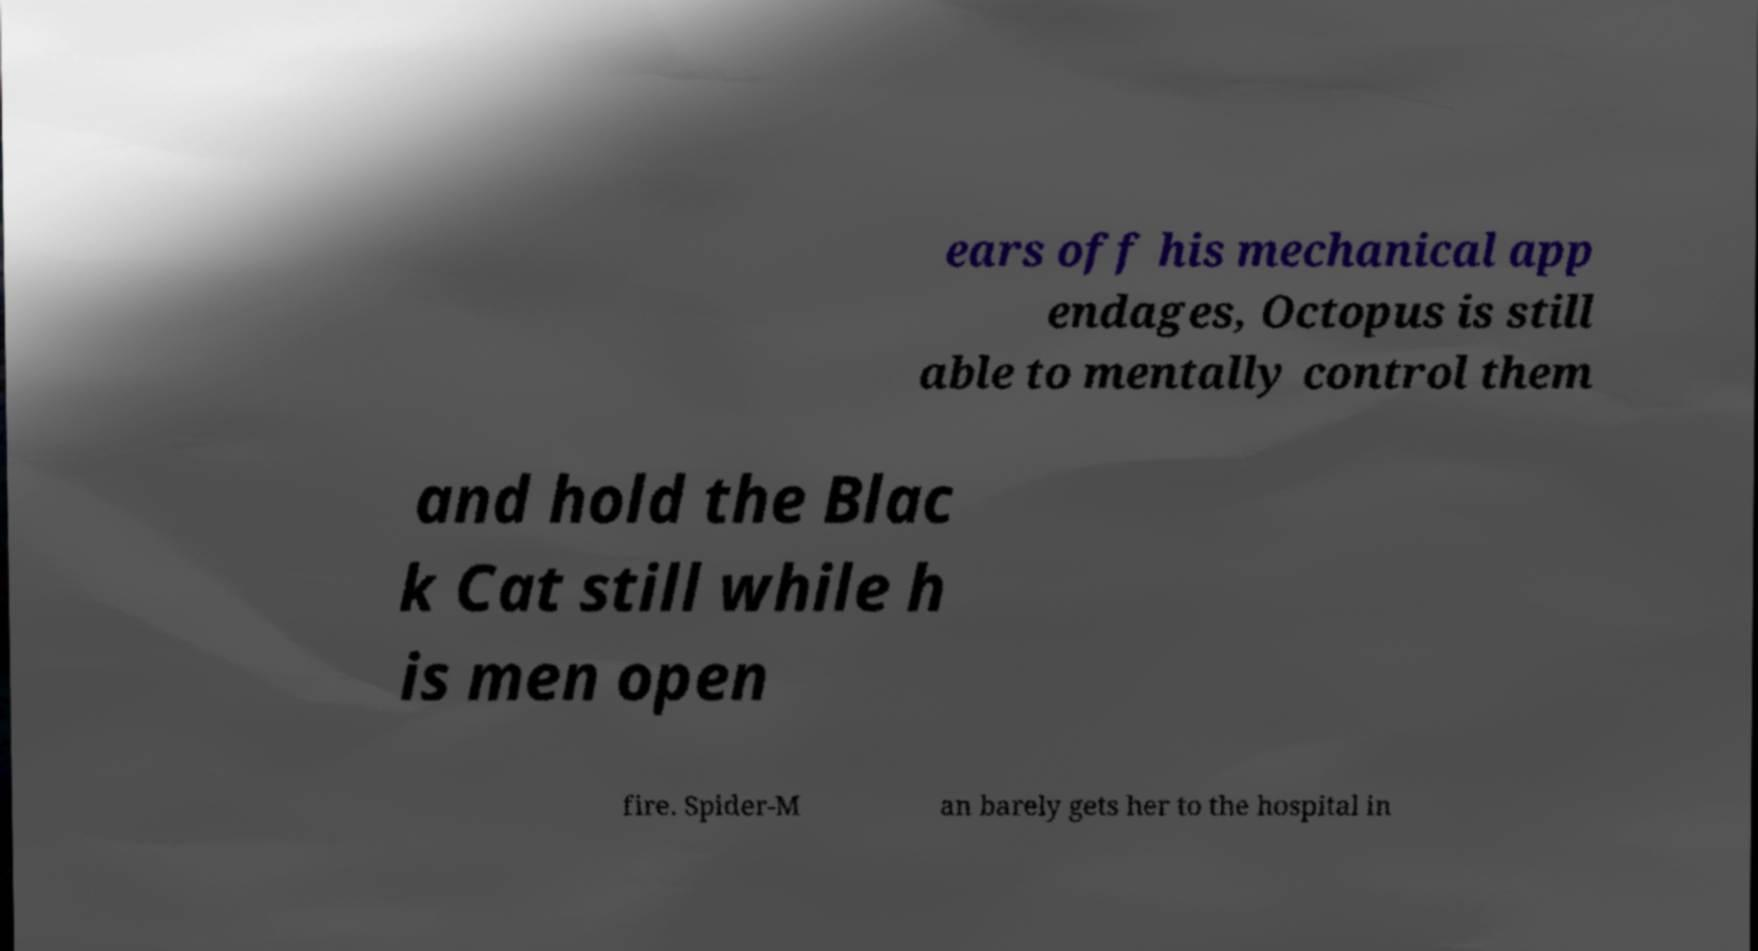Please identify and transcribe the text found in this image. ears off his mechanical app endages, Octopus is still able to mentally control them and hold the Blac k Cat still while h is men open fire. Spider-M an barely gets her to the hospital in 